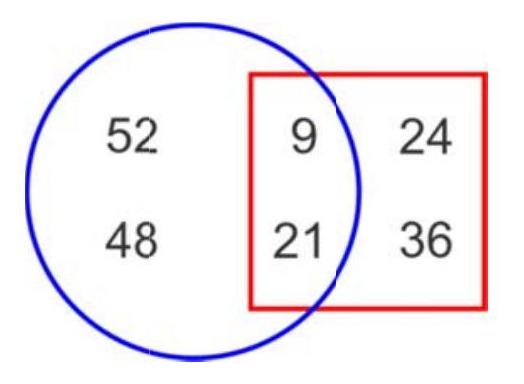What numbers are inside both the circle and the square? The numbers inside both the circle and the square are 9, 21, 24, and 36. 